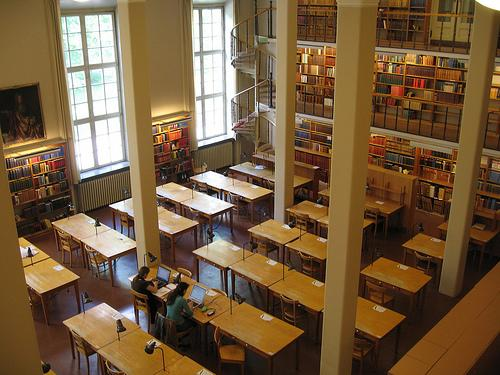What are the two people doing in the image and where are they doing it? Two people are doing research in a library, sitting at a table together. Are there any pieces of artwork or decoration visible in the image? There is a painting on the wall and a lovely spiral staircase. In a few sentences, describe the library setting in this image. The library has shelves of books, long windows, a spiral staircase, and rows of empty desks. There is track lighting illuminating the books, and a railing on the second floor. Examine the image carefully and describe a unique architectural feature that you see. A lovely spiral staircase is present, winding upwards in the library. Narrate the scene and mention the major objects visible in the image. In a library with shelves of books and long windows, two people are sitting at a table doing research. There is a painting on the wall, a spiral staircase, rows of empty desks, and a railing on the second floor. What is the main activity taking place in this image? People are researching and working on laptops in a library. Identify the type of shirt that someone in the image is wearing. A green long sleeve shirt. Describe the atmosphere of the given image in a single sentence. A quiet, studious environment with several people working diligently in a well-lit library. Count the number of people, laptops, and lamps in the image. Two people, two laptops, and two lamps. List all the major types of objects present in the image. People, bookshelves, windows, desks, painting, spiral staircase, railing, laptop, lamp, and lighting. 